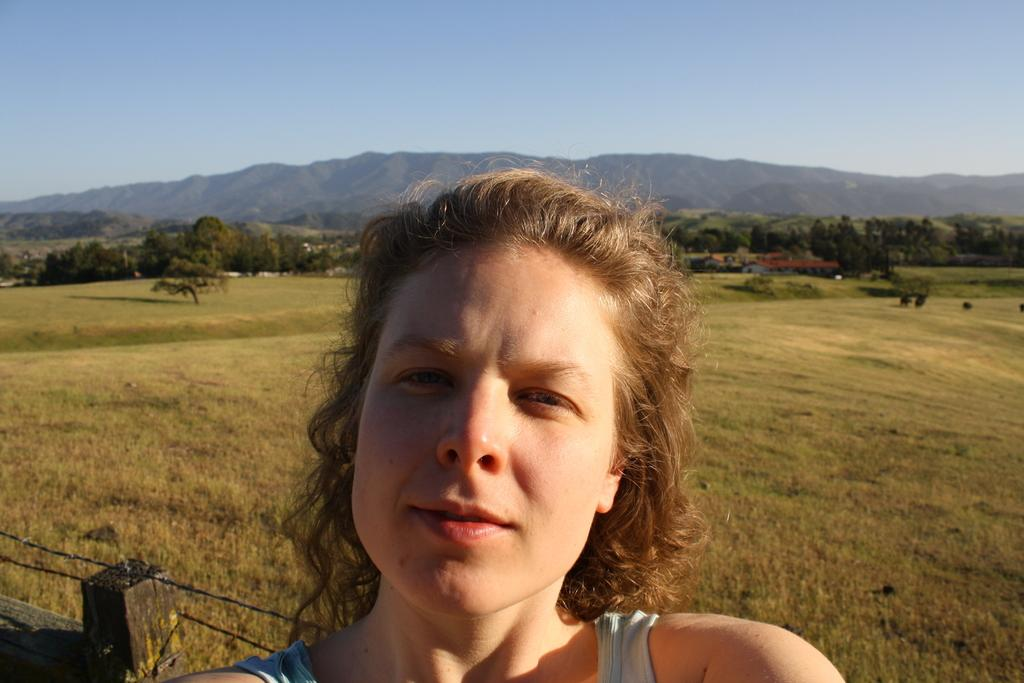Who is present in the image? There is a woman in the image. What is the woman's expression? The woman is smiling. What can be seen in the foreground of the image? There appears to be a fence in the image. What type of vegetation is visible in the image? There is grass and trees visible in the image. What type of structure is visible in the background of the image? There is a house in the background of the image. What natural feature can be seen in the distance? There are mountains visible in the background of the image. What type of feather can be seen falling from the sky in the image? There is no feather visible falling from the sky in the image. 